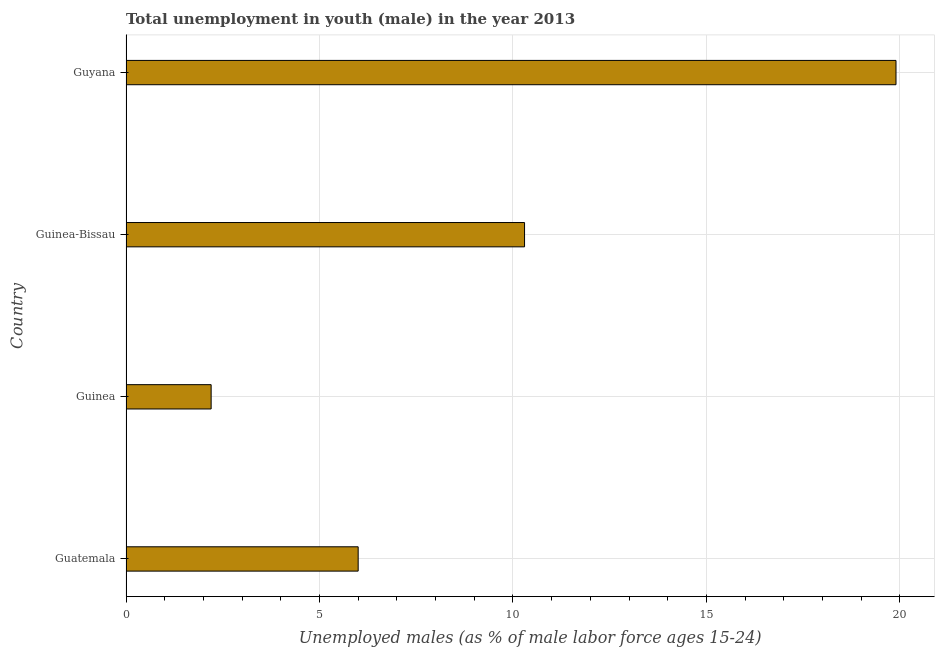What is the title of the graph?
Your response must be concise. Total unemployment in youth (male) in the year 2013. What is the label or title of the X-axis?
Offer a terse response. Unemployed males (as % of male labor force ages 15-24). What is the label or title of the Y-axis?
Offer a very short reply. Country. What is the unemployed male youth population in Guyana?
Your response must be concise. 19.9. Across all countries, what is the maximum unemployed male youth population?
Your answer should be very brief. 19.9. Across all countries, what is the minimum unemployed male youth population?
Keep it short and to the point. 2.2. In which country was the unemployed male youth population maximum?
Make the answer very short. Guyana. In which country was the unemployed male youth population minimum?
Ensure brevity in your answer.  Guinea. What is the sum of the unemployed male youth population?
Offer a very short reply. 38.4. What is the median unemployed male youth population?
Ensure brevity in your answer.  8.15. What is the ratio of the unemployed male youth population in Guinea to that in Guinea-Bissau?
Your answer should be very brief. 0.21. What is the difference between the highest and the second highest unemployed male youth population?
Provide a short and direct response. 9.6. What is the difference between the highest and the lowest unemployed male youth population?
Offer a terse response. 17.7. In how many countries, is the unemployed male youth population greater than the average unemployed male youth population taken over all countries?
Ensure brevity in your answer.  2. How many bars are there?
Your response must be concise. 4. Are all the bars in the graph horizontal?
Your answer should be compact. Yes. How many countries are there in the graph?
Make the answer very short. 4. What is the Unemployed males (as % of male labor force ages 15-24) of Guatemala?
Offer a terse response. 6. What is the Unemployed males (as % of male labor force ages 15-24) in Guinea?
Give a very brief answer. 2.2. What is the Unemployed males (as % of male labor force ages 15-24) of Guinea-Bissau?
Keep it short and to the point. 10.3. What is the Unemployed males (as % of male labor force ages 15-24) in Guyana?
Make the answer very short. 19.9. What is the difference between the Unemployed males (as % of male labor force ages 15-24) in Guatemala and Guinea?
Your response must be concise. 3.8. What is the difference between the Unemployed males (as % of male labor force ages 15-24) in Guinea and Guyana?
Your answer should be compact. -17.7. What is the ratio of the Unemployed males (as % of male labor force ages 15-24) in Guatemala to that in Guinea?
Keep it short and to the point. 2.73. What is the ratio of the Unemployed males (as % of male labor force ages 15-24) in Guatemala to that in Guinea-Bissau?
Your answer should be compact. 0.58. What is the ratio of the Unemployed males (as % of male labor force ages 15-24) in Guatemala to that in Guyana?
Your response must be concise. 0.3. What is the ratio of the Unemployed males (as % of male labor force ages 15-24) in Guinea to that in Guinea-Bissau?
Offer a terse response. 0.21. What is the ratio of the Unemployed males (as % of male labor force ages 15-24) in Guinea to that in Guyana?
Make the answer very short. 0.11. What is the ratio of the Unemployed males (as % of male labor force ages 15-24) in Guinea-Bissau to that in Guyana?
Your answer should be very brief. 0.52. 